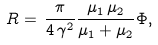Convert formula to latex. <formula><loc_0><loc_0><loc_500><loc_500>R = \, \frac { \pi } { 4 \, \gamma ^ { 2 } } \frac { \mu _ { 1 } \, \mu _ { 2 } } { \mu _ { 1 } + \mu _ { 2 } } \Phi ,</formula> 